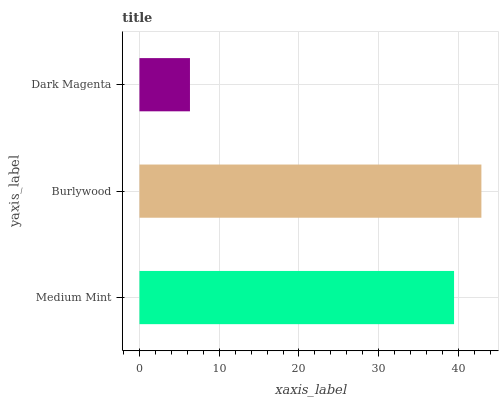Is Dark Magenta the minimum?
Answer yes or no. Yes. Is Burlywood the maximum?
Answer yes or no. Yes. Is Burlywood the minimum?
Answer yes or no. No. Is Dark Magenta the maximum?
Answer yes or no. No. Is Burlywood greater than Dark Magenta?
Answer yes or no. Yes. Is Dark Magenta less than Burlywood?
Answer yes or no. Yes. Is Dark Magenta greater than Burlywood?
Answer yes or no. No. Is Burlywood less than Dark Magenta?
Answer yes or no. No. Is Medium Mint the high median?
Answer yes or no. Yes. Is Medium Mint the low median?
Answer yes or no. Yes. Is Dark Magenta the high median?
Answer yes or no. No. Is Burlywood the low median?
Answer yes or no. No. 